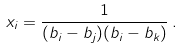Convert formula to latex. <formula><loc_0><loc_0><loc_500><loc_500>x _ { i } = \frac { 1 } { ( b _ { i } - b _ { j } ) ( b _ { i } - b _ { k } ) } \, .</formula> 